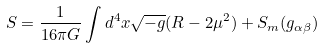<formula> <loc_0><loc_0><loc_500><loc_500>S = \frac { 1 } { 1 6 \pi G } \int d ^ { 4 } x \sqrt { - g } ( R - 2 \mu ^ { 2 } ) + S _ { m } ( g _ { \alpha \beta } )</formula> 